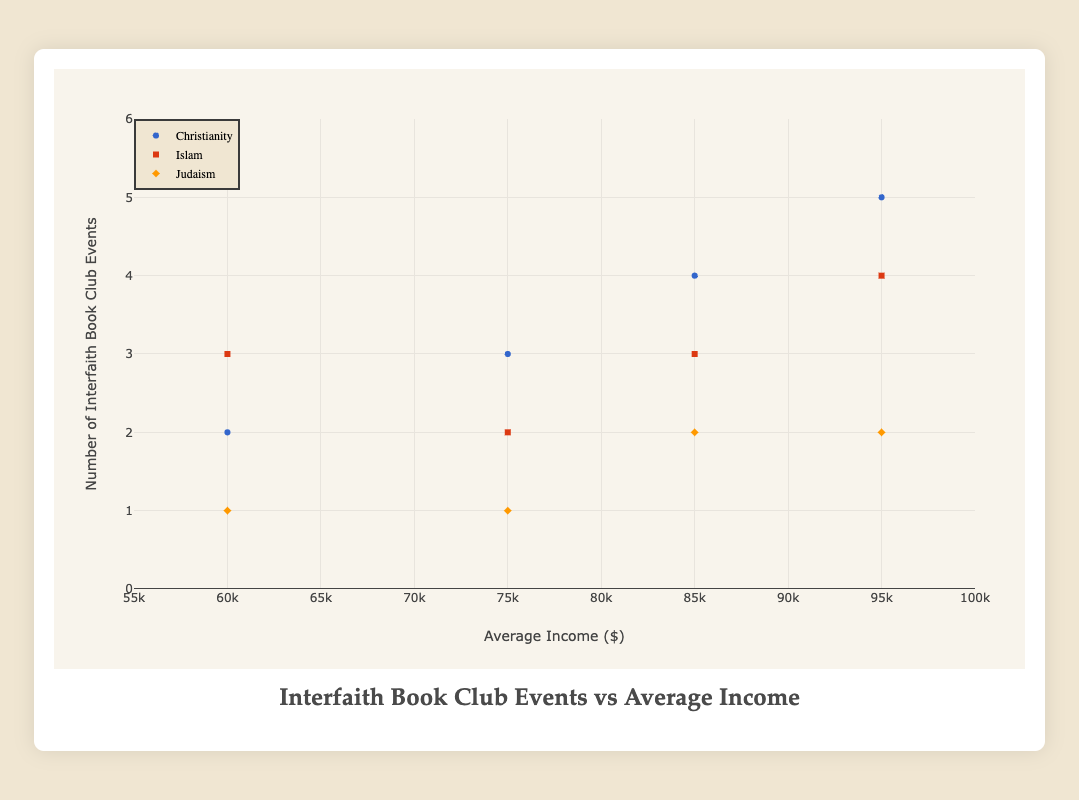What's the title of the figure? The title is typically found at the top of the figure and provides a brief description of what the chart is about. In this case, the title is "Interfaith Book Club Events vs Average Income."
Answer: Interfaith Book Club Events vs Average Income What does the x-axis represent, and what is its range? The x-axis represents the average income in dollars. According to the chart, the range is from $55,000 to $100,000.
Answer: Average Income from $55,000 to $100,000 Which neighborhood has the highest number of interfaith book club events, and what is the average income for that neighborhood? The plot shows that the highest number of interfaith book club events is 5, which occurs in the Riverside neighborhood. The average income for Riverside is $95,000.
Answer: Riverside with $95,000 How many interfaith book club events are hosted by the Judaism group in Urban Plains? By examining the plot, we can see that the Judaism group in Urban Plains hosts 1 interfaith book club event.
Answer: 1 Which religion in Metropolitan Heights hosts the most interfaith book club events? In the plot, we can see that Christianity hosts the highest number of events in Metropolitan Heights, with 4 interfaith book club events.
Answer: Christianity Compare the number of interfaith book club events hosted by Christianity in Metropolitan Heights and Suburban Gardens. Which neighborhood has more events? According to the plot, Christianity in Metropolitan Heights hosts 4 events, while in Suburban Gardens it hosts 3 events. Therefore, Metropolitan Heights has more events.
Answer: Metropolitan Heights Which neighborhood has the lowest average income, and how many interfaith book club events are hosted there by Islam? The neighborhood with the lowest average income is Urban Plains, with $60,000. The Islam group there hosts 3 interfaith book club events.
Answer: Urban Plains with 3 events Compare the number of interfaith book club events hosted by Judaism in Riverside and Suburban Gardens. How many more events are hosted in Riverside? The plot shows that Judaism in Riverside hosts 2 events, while in Suburban Gardens it hosts 1 event. Therefore, Riverside hosts 1 more event than Suburban Gardens.
Answer: 1 more event Calculate the average number of interfaith book club events for Islam across all neighborhoods. Islam hosts 3 events in Metropolitan Heights, 3 in Urban Plains, 4 in Riverside, and 2 in Suburban Gardens. Adding these gives us 3 + 3 + 4 + 2 = 12. Dividing by 4 neighborhoods, we get an average of 12/4 = 3.
Answer: 3 Which religion is represented by the square marker, and what is its color? By referring to the plot legend, we see that the square marker is used for Islam, and the color is red.
Answer: Islam with red marker 